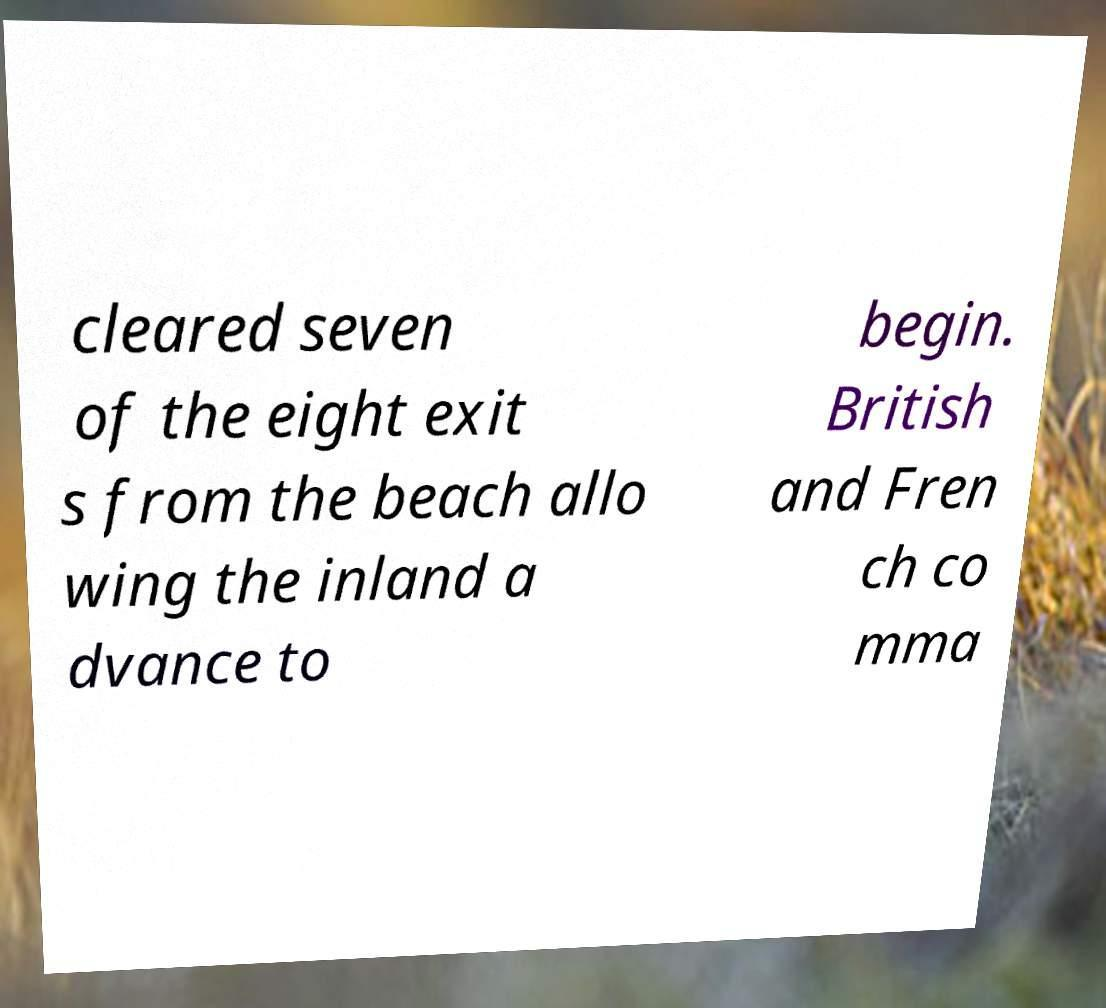For documentation purposes, I need the text within this image transcribed. Could you provide that? cleared seven of the eight exit s from the beach allo wing the inland a dvance to begin. British and Fren ch co mma 